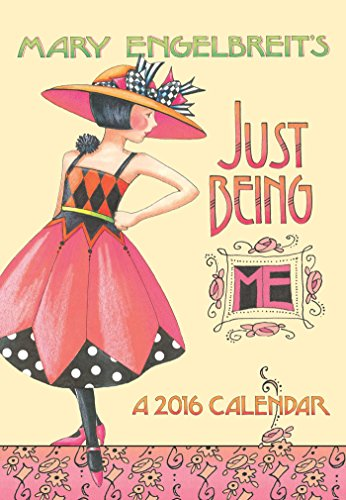What might be the significance of the artistic style used on this cover? Mary Engelbreit is known for her distinctive, colorful illustrations that often include bold patterns and nostalgic imagery. The artistic style on this cover likely aims to mirror her signature approach, evoking a sense of whimsy and charm. This style makes the planner not only a useful tool but also a delightful piece of art that appeals to those who appreciate visual storytelling and artwork in their everyday items. 